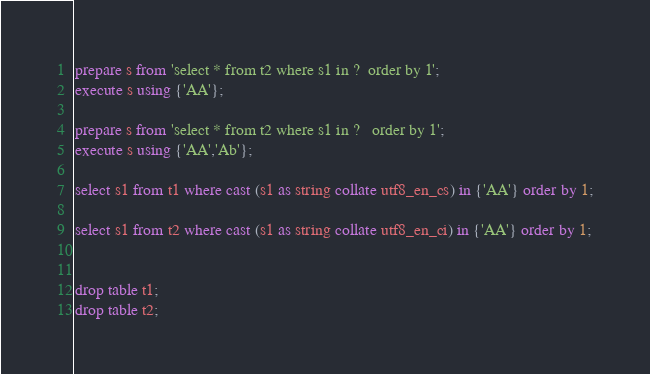<code> <loc_0><loc_0><loc_500><loc_500><_SQL_>prepare s from 'select * from t2 where s1 in ?  order by 1';
execute s using {'AA'};

prepare s from 'select * from t2 where s1 in ?   order by 1';
execute s using {'AA','Ab'};

select s1 from t1 where cast (s1 as string collate utf8_en_cs) in {'AA'} order by 1;

select s1 from t2 where cast (s1 as string collate utf8_en_ci) in {'AA'} order by 1;


drop table t1;
drop table t2;
</code> 